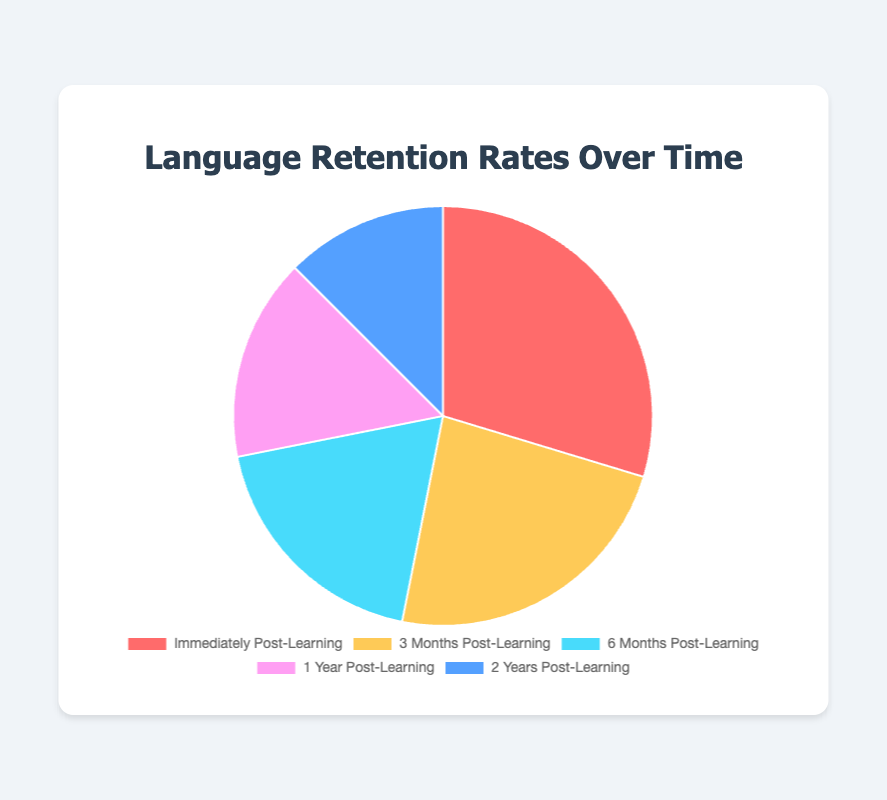What is the retention rate immediately post-learning? The slice labeled "Immediately Post-Learning" shows a retention rate of 95%, as indicated in the corresponding segment of the pie chart.
Answer: 95% Which duration has the lowest language retention rate? The segment for "2 Years Post-Learning" shows the lowest retention rate at 40%, based on the visual information.
Answer: 2 Years Post-Learning How does the retention rate 3 months post-learning compare to 1 year post-learning? The retention rate 3 months post-learning is 75%, while 1 year post-learning is 50%. Comparing these, 3 months post-learning has a higher retention rate than 1 year post-learning.
Answer: 3 months post-learning has a higher retention rate What is the difference in retention rate between 6 months and 2 years post-learning? The retention rate for 6 months post-learning is 60%, while for 2 years post-learning it is 40%. The difference is 60% - 40% = 20%.
Answer: 20% Which duration has a retention rate that is exactly halfway between the retention rates for immediately post-learning and 2 years post-learning? The retention rate immediately post-learning is 95% and for 2 years post-learning it is 40%. The halfway point is (95% + 40%) / 2 = 67.5%. The closest retention rate is at 6 months post-learning, which is 60%.
Answer: 6 months post-learning What two durations have the highest combined (sum) retention rate? The retention rates for immediately post-learning and 3 months post-learning are 95% and 75%, respectively. Their combined retention rate is 95% + 75% = 170%, which is the highest sum among the durations.
Answer: Immediately post-learning and 3 months post-learning Which color represents the segment with the retention rate 1 year post-learning? The segment for "1 Year Post-Learning" is filled in purple.
Answer: Purple By how much does the retention rate decrease from 3 months to 1 year post-learning? The retention rate at 3 months is 75%, and at 1 year it is 50%. The decrease is 75% - 50% = 25%.
Answer: 25% What is the average retention rate over all durations mentioned? Summing up the retention rates: 95% + 75% + 60% + 50% + 40% = 320%, and dividing by the number of data points (5) gives the average: 320% / 5 = 64%.
Answer: 64% 